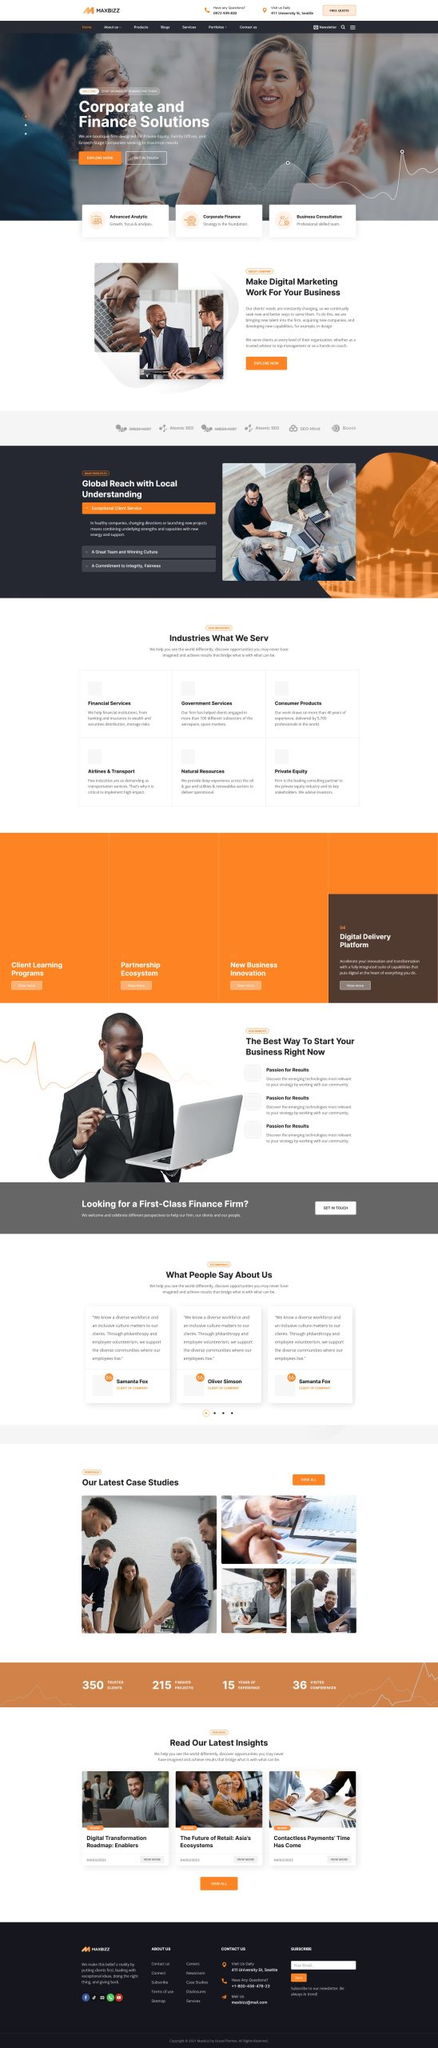Liệt kê 5 ngành nghề, lĩnh vực phù hợp với website này, phân cách các màu sắc bằng dấu phẩy. Chỉ trả về kết quả, phân cách bằng dấy phẩy
 Financial Services, Government Services, Consumer Products, Airlines & Transport, Natural Resources 